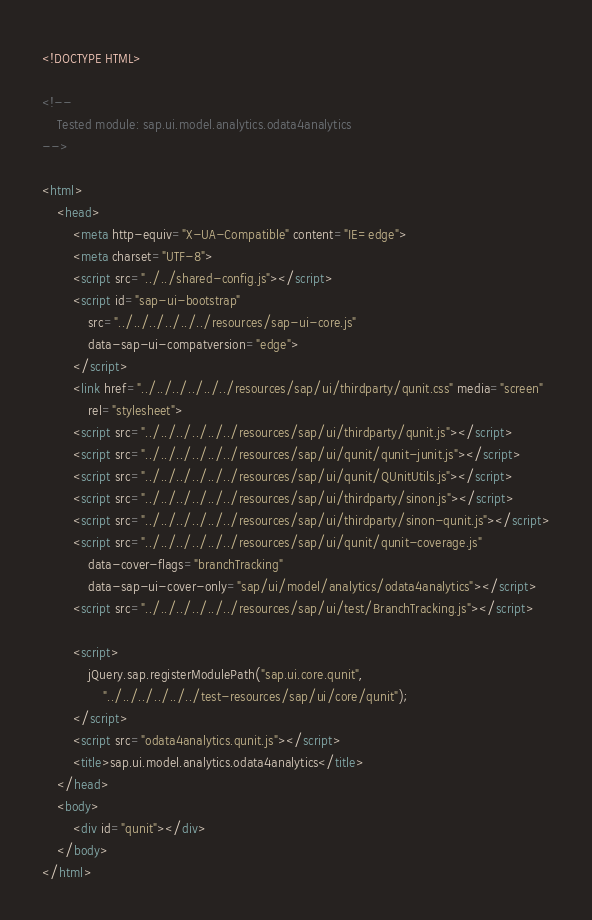<code> <loc_0><loc_0><loc_500><loc_500><_HTML_><!DOCTYPE HTML>

<!--
	Tested module: sap.ui.model.analytics.odata4analytics
-->

<html>
	<head>
		<meta http-equiv="X-UA-Compatible" content="IE=edge">
		<meta charset="UTF-8">
		<script src="../../shared-config.js"></script>
		<script id="sap-ui-bootstrap"
			src="../../../../../../resources/sap-ui-core.js"
			data-sap-ui-compatversion="edge">
		</script>
		<link href="../../../../../../resources/sap/ui/thirdparty/qunit.css" media="screen"
			rel="stylesheet">
		<script src="../../../../../../resources/sap/ui/thirdparty/qunit.js"></script>
		<script src="../../../../../../resources/sap/ui/qunit/qunit-junit.js"></script>
		<script src="../../../../../../resources/sap/ui/qunit/QUnitUtils.js"></script>
		<script src="../../../../../../resources/sap/ui/thirdparty/sinon.js"></script>
		<script src="../../../../../../resources/sap/ui/thirdparty/sinon-qunit.js"></script>
		<script src="../../../../../../resources/sap/ui/qunit/qunit-coverage.js"
			data-cover-flags="branchTracking"
			data-sap-ui-cover-only="sap/ui/model/analytics/odata4analytics"></script>
		<script src="../../../../../../resources/sap/ui/test/BranchTracking.js"></script>

		<script>
			jQuery.sap.registerModulePath("sap.ui.core.qunit",
				"../../../../../../test-resources/sap/ui/core/qunit");
		</script>
		<script src="odata4analytics.qunit.js"></script>
		<title>sap.ui.model.analytics.odata4analytics</title>
	</head>
	<body>
		<div id="qunit"></div>
	</body>
</html>
</code> 